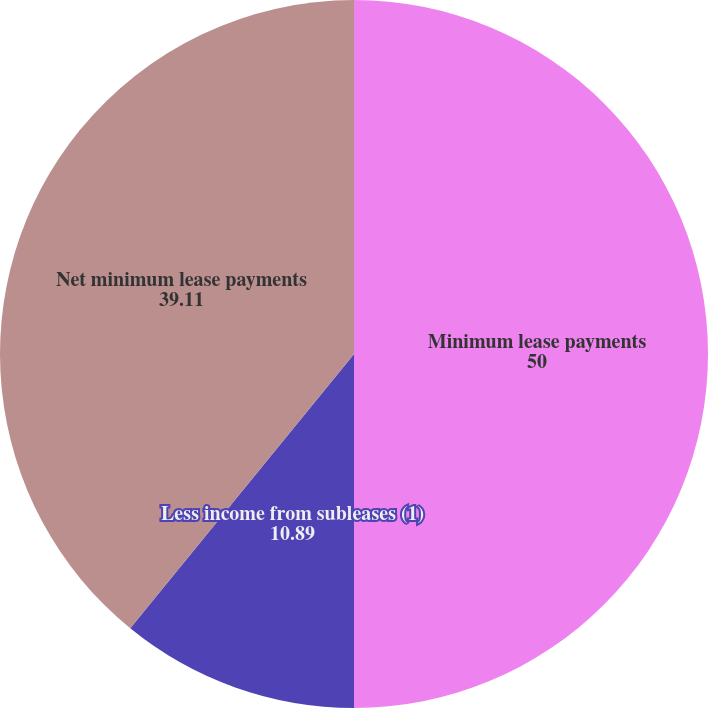Convert chart. <chart><loc_0><loc_0><loc_500><loc_500><pie_chart><fcel>Minimum lease payments<fcel>Less income from subleases (1)<fcel>Net minimum lease payments<nl><fcel>50.0%<fcel>10.89%<fcel>39.11%<nl></chart> 